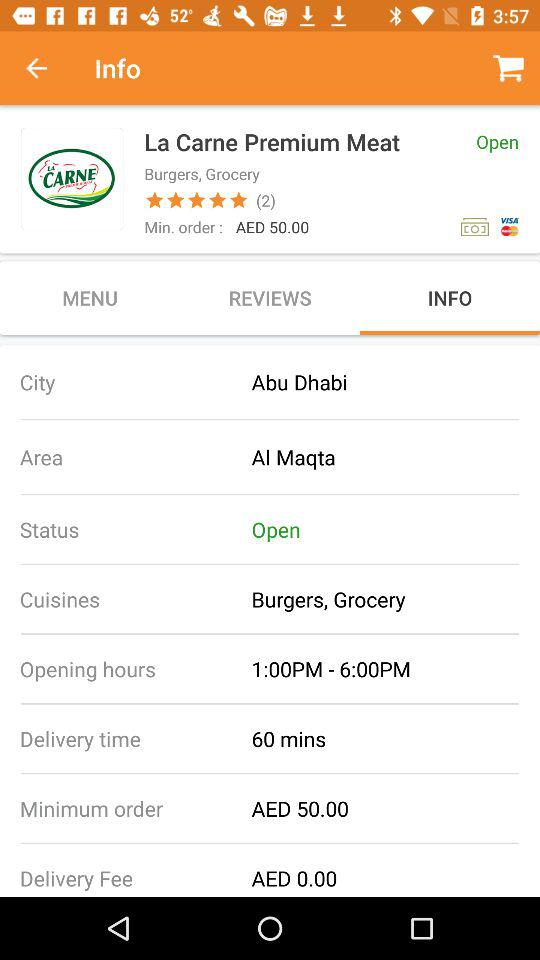How long will it take for your order to be delivered? It will take 60 minutes for your order to be delivered. 